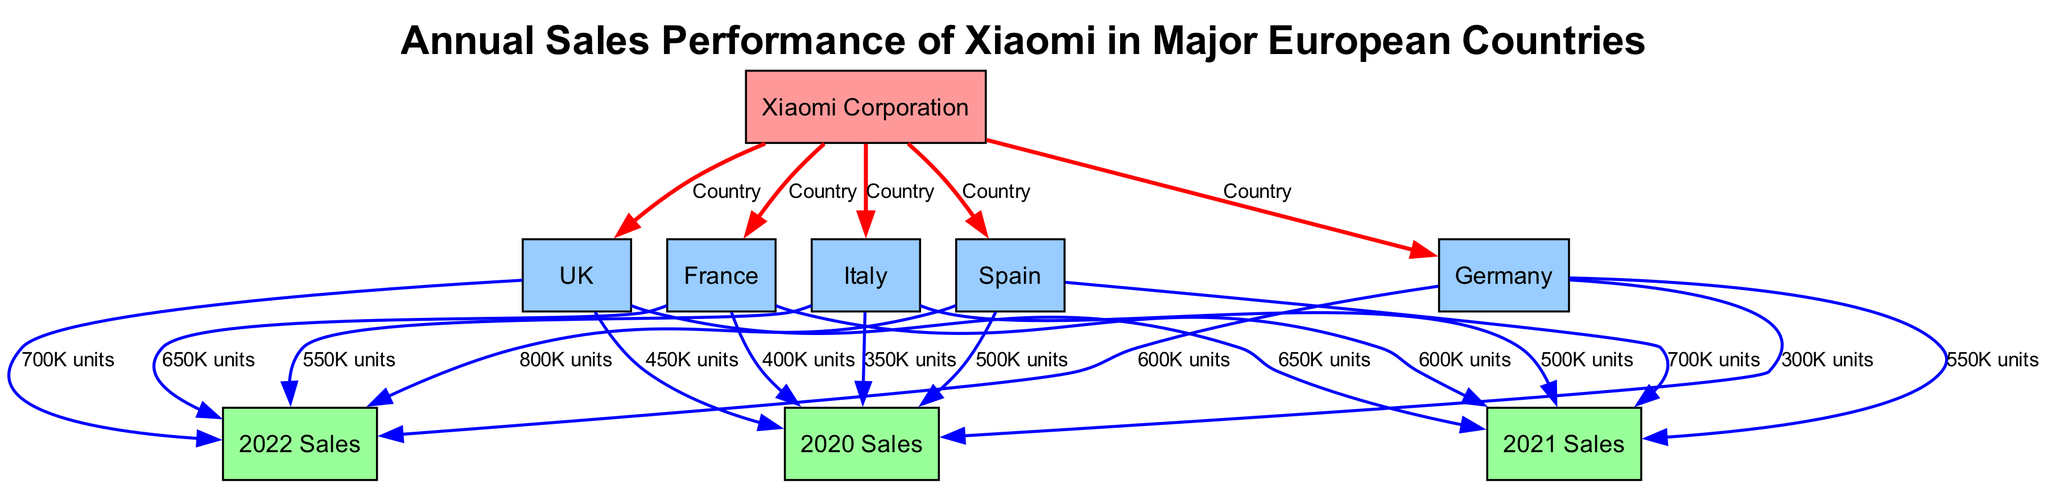What is the total sales in Spain in 2022? The diagram shows that the sales in Spain for the year 2022 is represented by an edge from Spain to the 2022 Sales node, which indicates a value of 800K units.
Answer: 800K units Which country had the highest sales in 2021? By comparing the sales for the year 2021 from each country represented in the diagram, it's observed that Spain had 700K units, Germany had 550K units, France had 600K units, Italy had 500K units, and the UK had 650K units. Since 700K units in Spain is the highest, it is the answer.
Answer: Spain How many countries are represented in the diagram? The diagram includes nodes for five different countries: Spain, Germany, France, Italy, and the UK. Thus, by counting these nodes, we find there are five countries represented.
Answer: 5 What is the sales growth in Germany from 2020 to 2022? To answer this, we look at the sales figures for Germany: in 2020 it was 300K units and in 2022 it was 600K units. The growth is calculated by subtracting the 2020 figure from the 2022 figure: 600K - 300K = 300K units.
Answer: 300K units Which year showed the lowest sales in France? Upon analyzing the sales figures for France in the years provided, we see 400K units in 2020, 600K units in 2021, and 650K in 2022. The lowest sales figure appears in 2020, as it is less than both the subsequent years.
Answer: 2020 What was the sales figure in the UK for 2021? The edge leading from the UK to the 2021 Sales node displays a label indicating the sales figure for that year. According to the diagram, the UK's sales in 2021 amounted to 650K units.
Answer: 650K units Which country had the lowest sales in 2020? By comparing the sales figures from the diagram: Spain had 500K units, Germany had 300K units, France had 400K units, Italy had 350K units, and the UK had 450K units, we can see that Germany had the lowest sales with 300K units in 2020.
Answer: Germany What sales increase did Italy experience from 2020 to 2022? For Italy, the 2020 sales were 350K units and in 2022 the sales were 550K units. The increase is determined by subtracting the 2020 figure from the 2022 figure: 550K - 350K = 200K units.
Answer: 200K units 